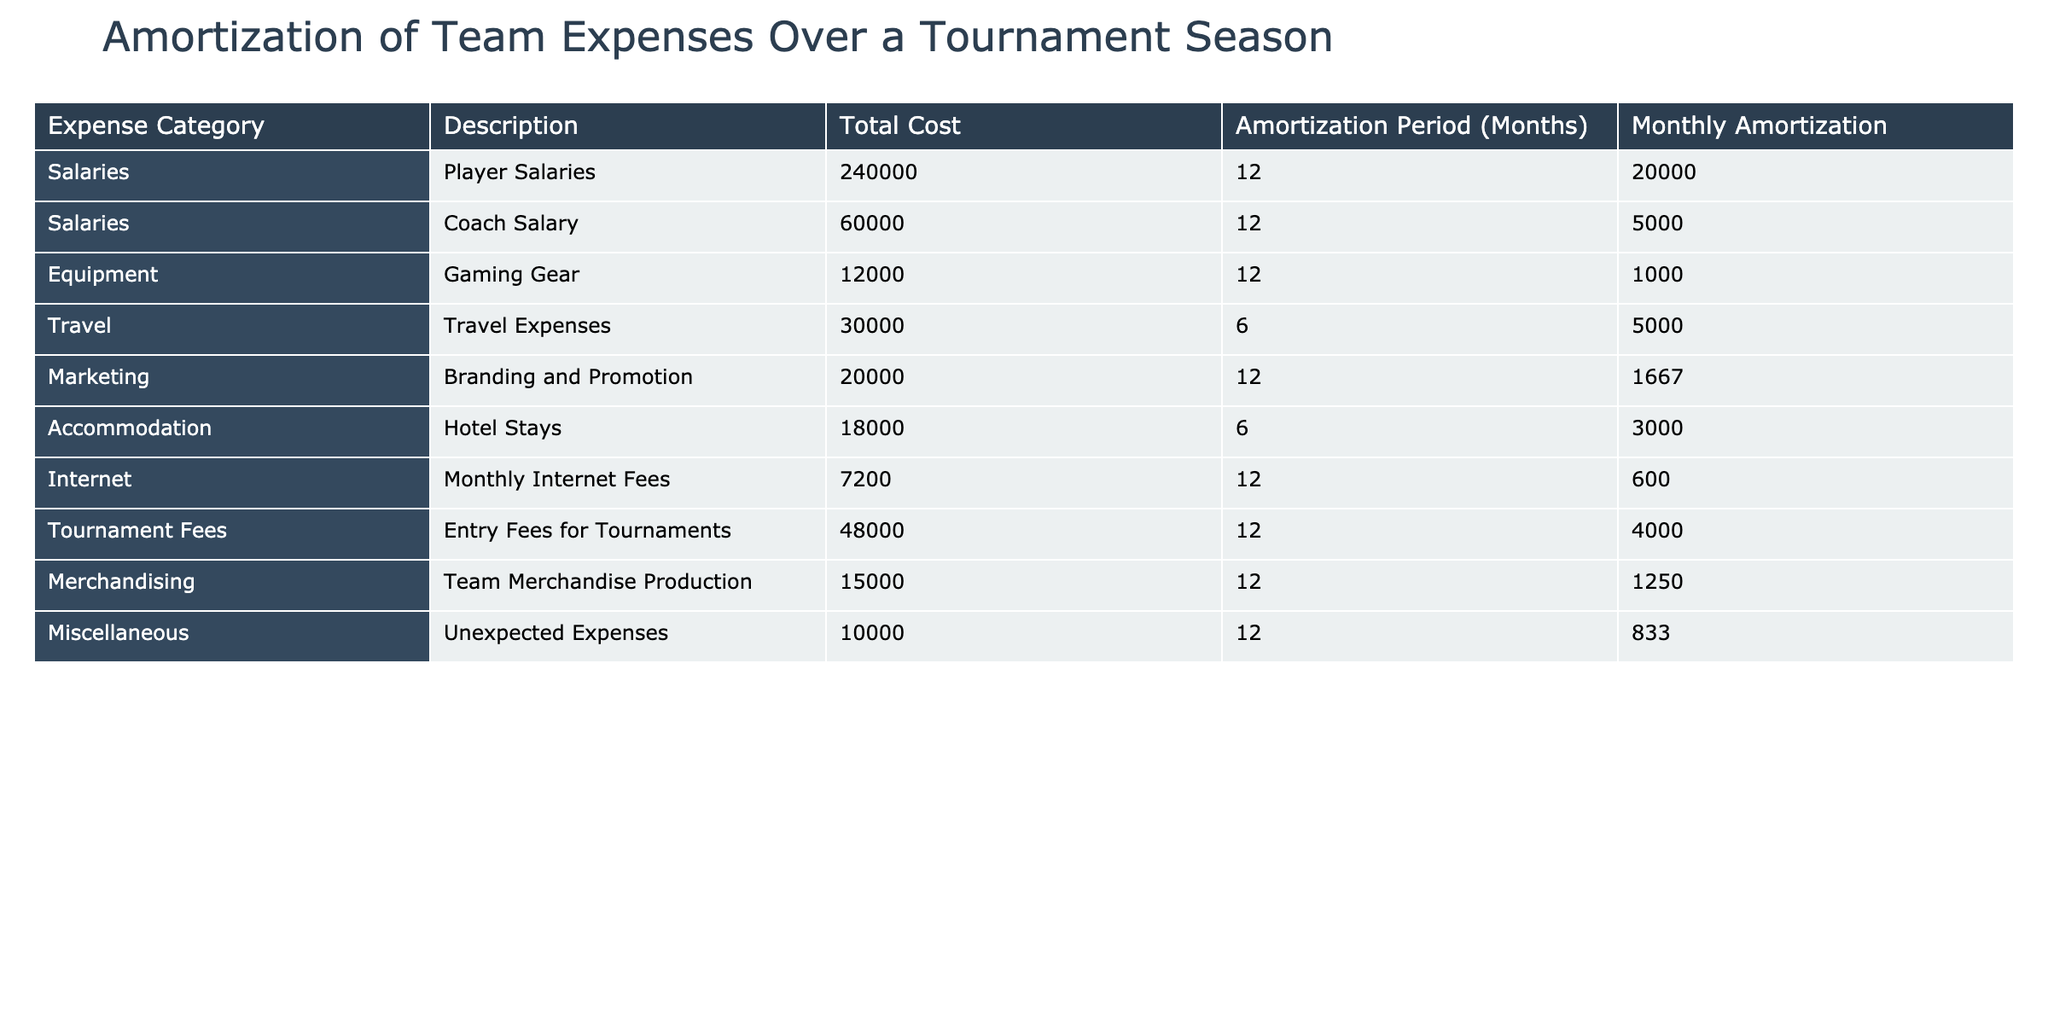What is the monthly amortization for player salaries? The table shows that the total cost for player salaries is 240000 and the amortization period is 12 months. The monthly amortization is directly provided in the table as 20000.
Answer: 20000 What is the total monthly amortization for travel and accommodation expenses combined? The monthly amortization for travel expenses is 5000 and for accommodation it is 3000. To find the total, we add these two amounts: 5000 + 3000 = 8000.
Answer: 8000 Is the monthly amortization for internet fees higher than that for marketing? The monthly amortization for internet fees is 600 while for marketing, it is 1667. Since 600 is less than 1667, the answer is no.
Answer: No What is the total cost for equipment and merchandising expenses? The total cost for gaming gear (equipment) is 12000 and for team merchandise production (merchandising) it is 15000. Adding these provides the total: 12000 + 15000 = 27000.
Answer: 27000 What is the average monthly amortization for all expenses listed? To calculate the average, first sum all monthly amortizations: 20000 + 5000 + 1000 + 5000 + 1667 + 3000 + 600 + 4000 + 1250 + 833 =  40000. With 10 expense categories, the average is 40000 / 10 = 4000.
Answer: 4000 Are travel expenses amortized over a longer period than accommodation expenses? The travel expenses are amortized over 6 months, while accommodation expenses are also amortized over 6 months. Since both are the same, the answer is no.
Answer: No What is the total cost for all expenses listed? By summing all total costs from the table: 240000 + 60000 + 12000 + 30000 + 20000 + 18000 + 7200 + 48000 + 15000 + 10000 = 384200.
Answer: 384200 How much more is spent on player salaries compared to coach salaries? The total cost for player salaries is 240000 and for coach salaries, it is 60000. To find the difference: 240000 - 60000 = 180000.
Answer: 180000 Which expense category has the lowest monthly amortization? The monthly amortization for internet fees is 600, and this is lower than all other expense categories. Thus, the category with the lowest monthly amortization is internet fees.
Answer: Internet Fees 